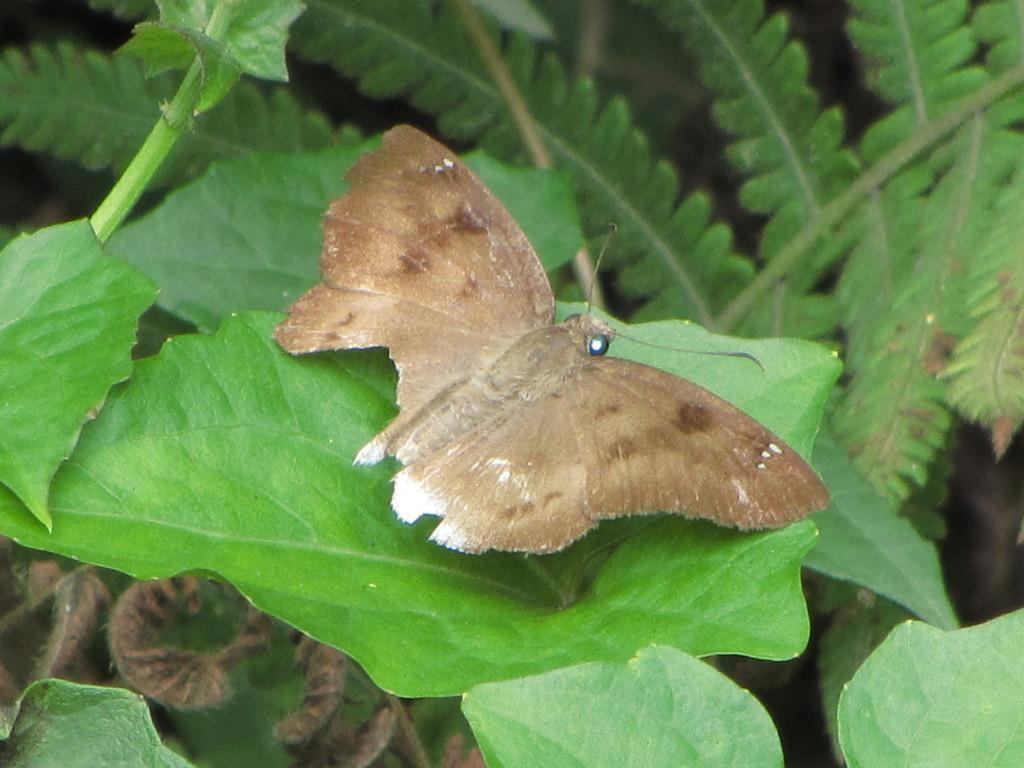What type of insect is in the image? There is a brown color butterfly in the image. Where is the butterfly located? The butterfly is on a leaf. What can be seen in the background of the image? There are trees visible in the image. What type of attention is the butterfly receiving at the zoo in the image? There is no zoo present in the image, and the butterfly is not receiving any attention. 